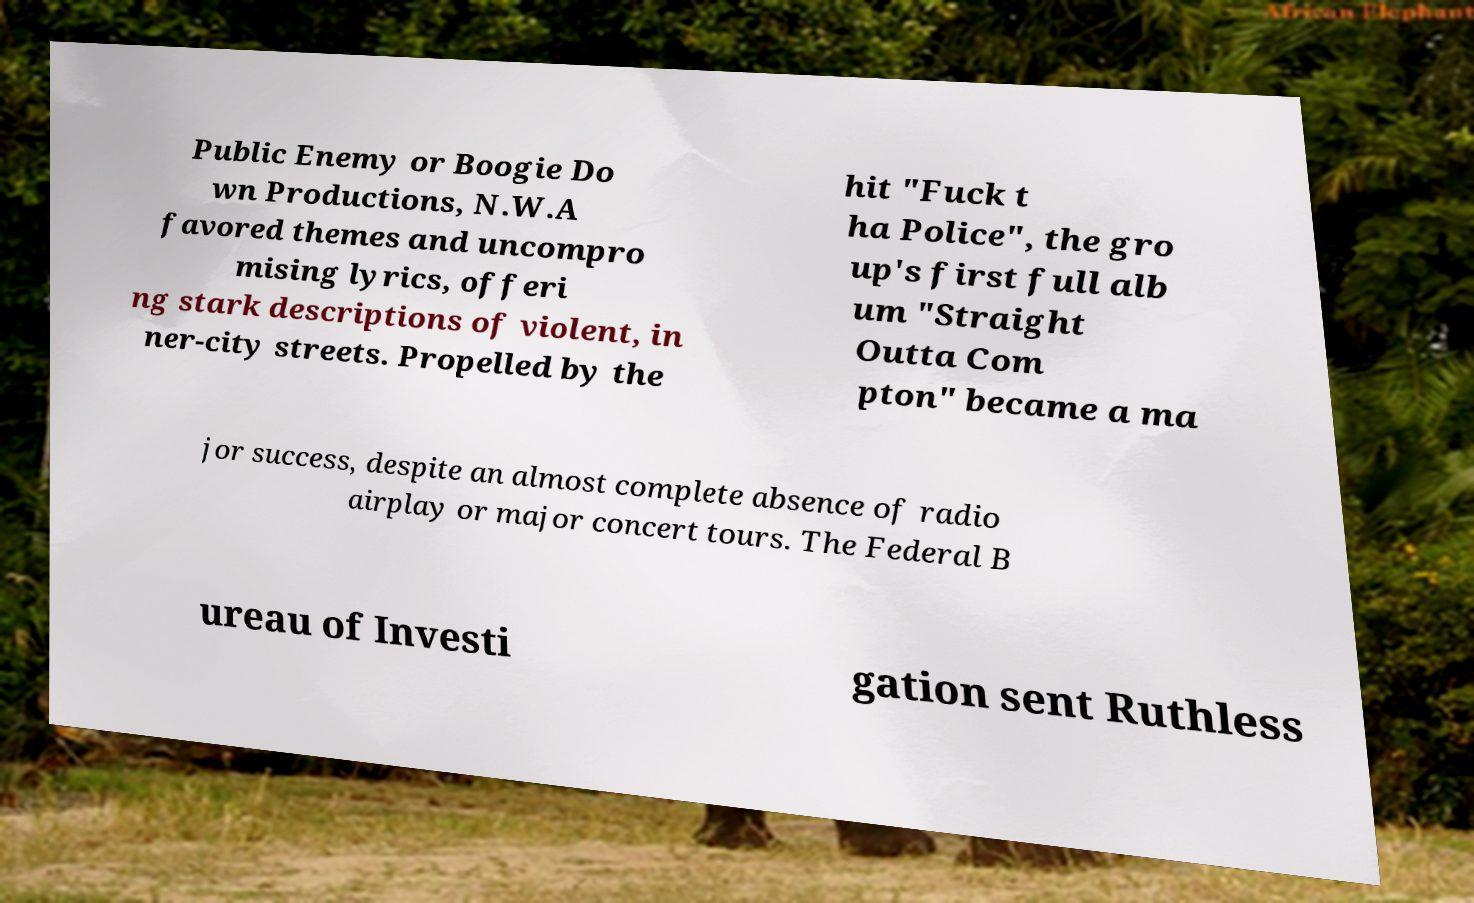There's text embedded in this image that I need extracted. Can you transcribe it verbatim? Public Enemy or Boogie Do wn Productions, N.W.A favored themes and uncompro mising lyrics, offeri ng stark descriptions of violent, in ner-city streets. Propelled by the hit "Fuck t ha Police", the gro up's first full alb um "Straight Outta Com pton" became a ma jor success, despite an almost complete absence of radio airplay or major concert tours. The Federal B ureau of Investi gation sent Ruthless 